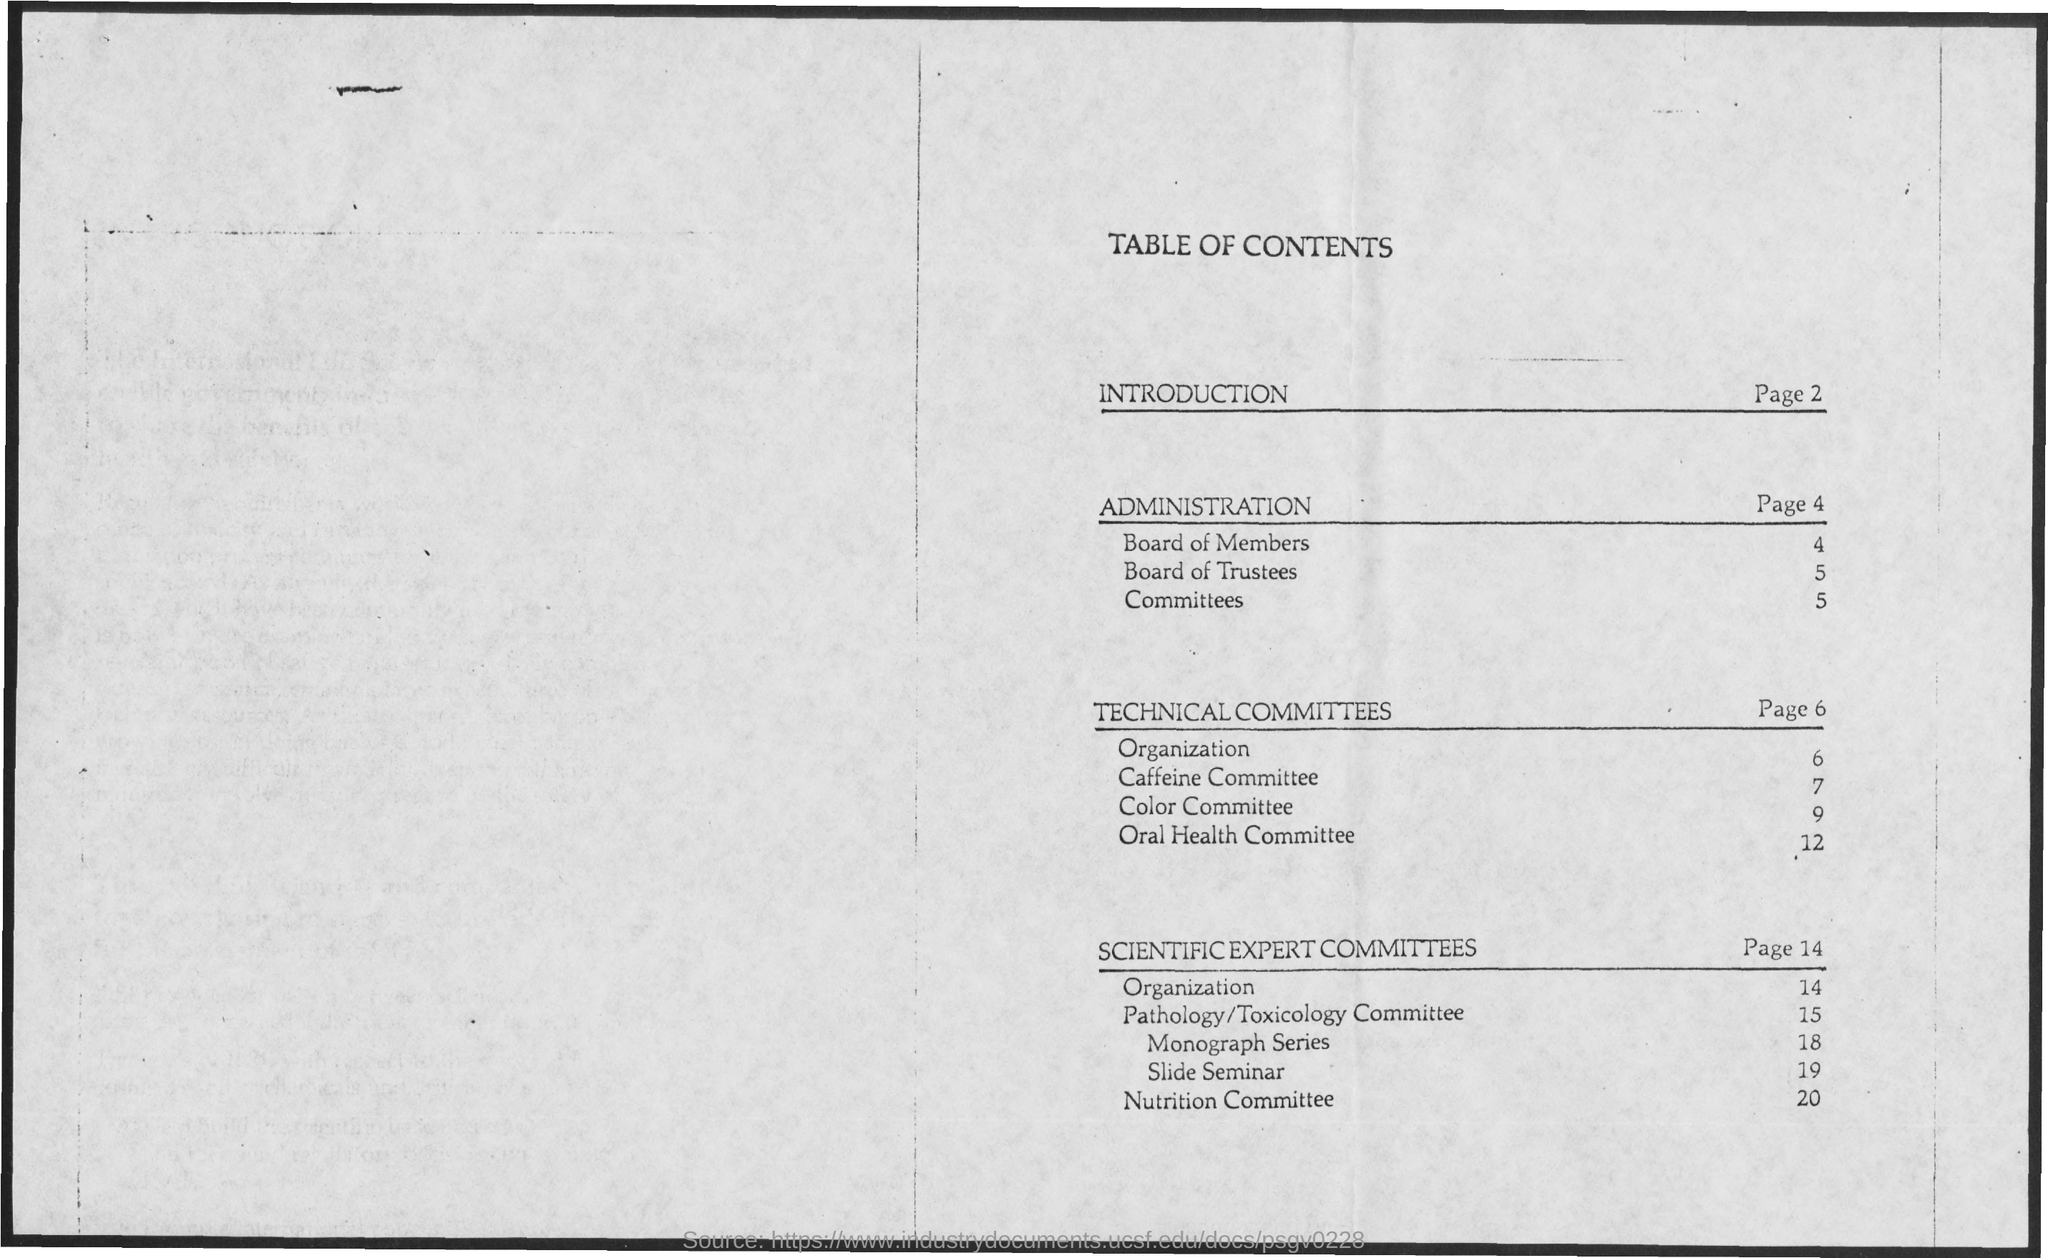What is the title of the document?
Ensure brevity in your answer.  Table of contents. The topic "Board of Members" is on which page?
Your response must be concise. 4. The topic "Nutrition Committee" is on which page?
Offer a terse response. 20. The topic "Slide Seminar" is on which page?
Your answer should be very brief. 19. The topic "Color Committee" is on which page?
Keep it short and to the point. 9. 